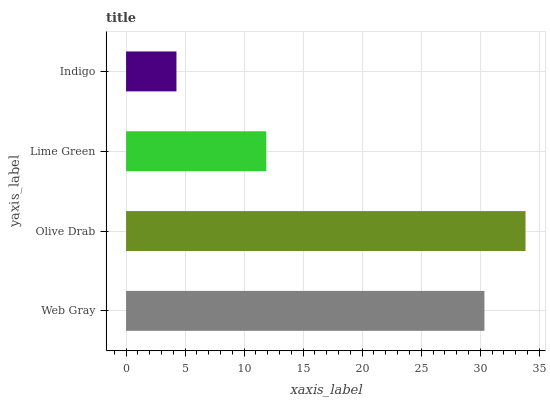Is Indigo the minimum?
Answer yes or no. Yes. Is Olive Drab the maximum?
Answer yes or no. Yes. Is Lime Green the minimum?
Answer yes or no. No. Is Lime Green the maximum?
Answer yes or no. No. Is Olive Drab greater than Lime Green?
Answer yes or no. Yes. Is Lime Green less than Olive Drab?
Answer yes or no. Yes. Is Lime Green greater than Olive Drab?
Answer yes or no. No. Is Olive Drab less than Lime Green?
Answer yes or no. No. Is Web Gray the high median?
Answer yes or no. Yes. Is Lime Green the low median?
Answer yes or no. Yes. Is Indigo the high median?
Answer yes or no. No. Is Indigo the low median?
Answer yes or no. No. 